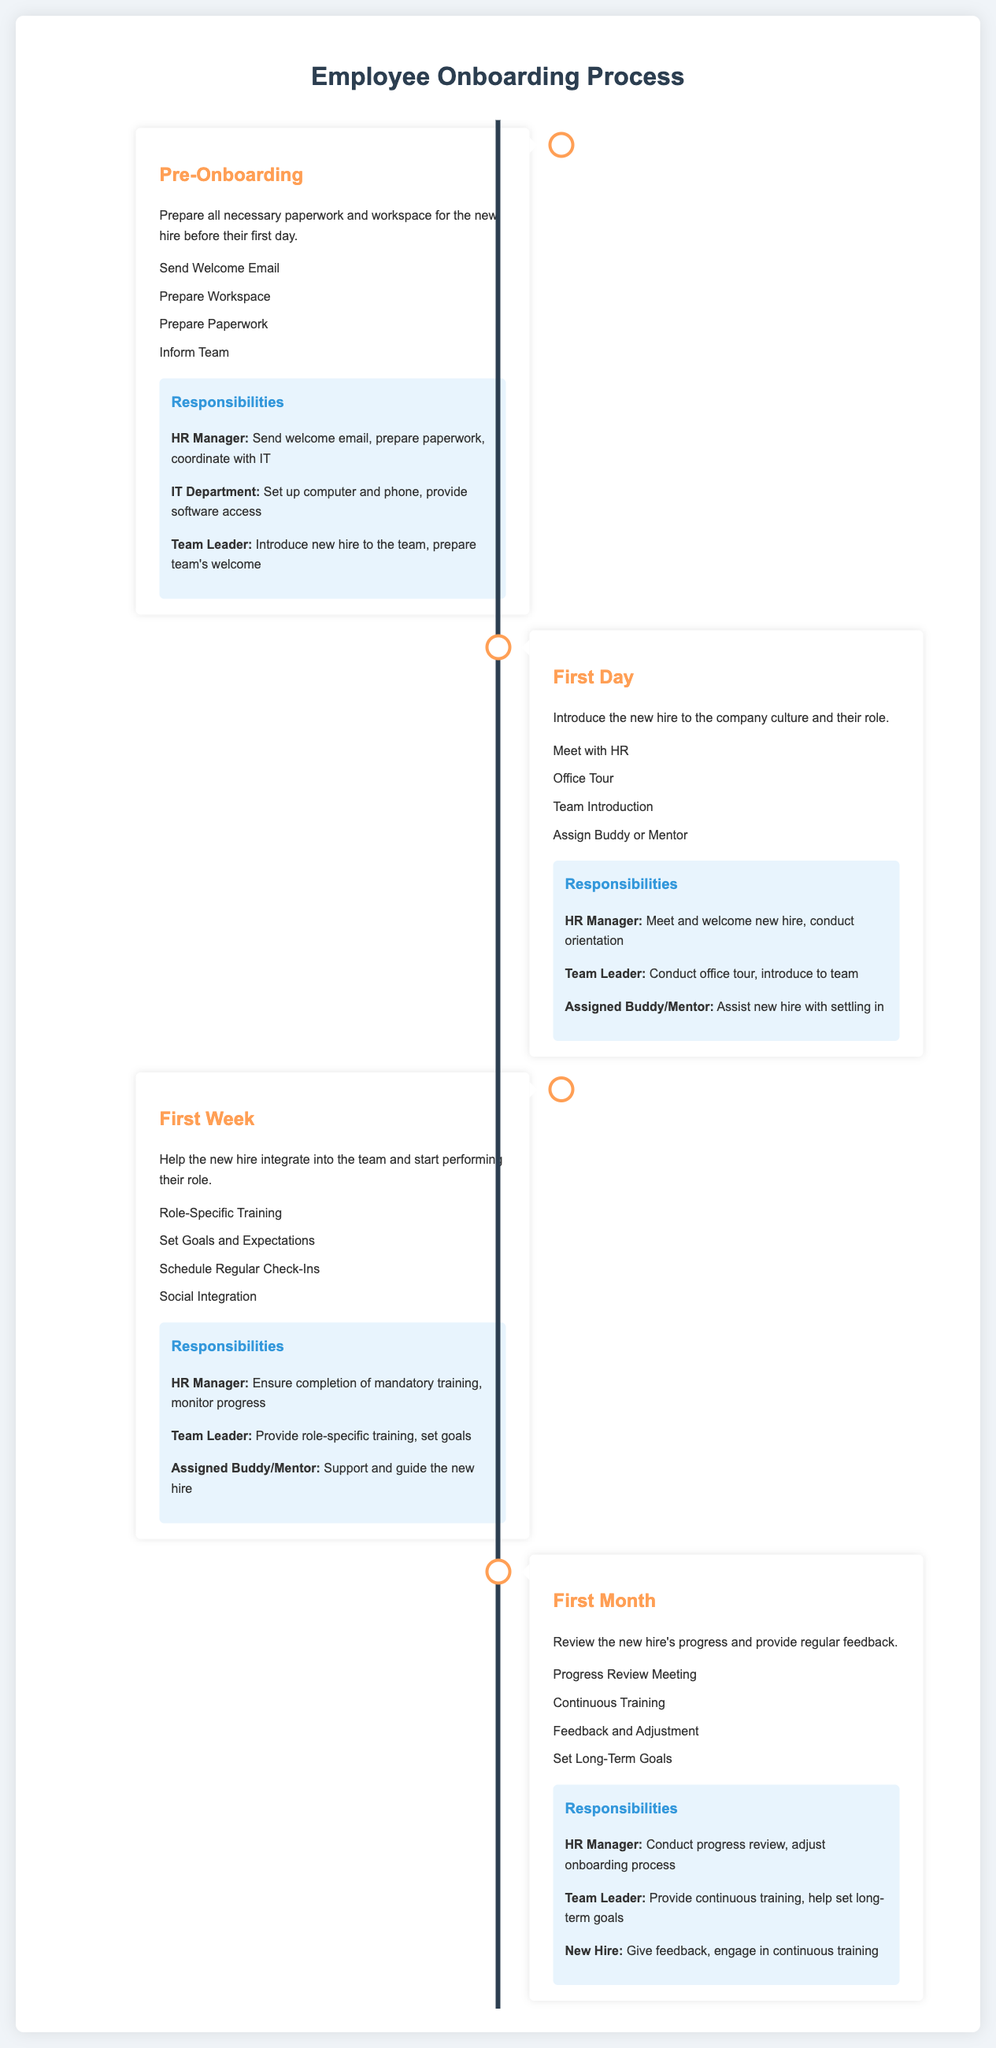What are the key phases of the onboarding process? The document lists four key phases: Pre-Onboarding, First Day, First Week, and First Month.
Answer: Pre-Onboarding, First Day, First Week, First Month Who is responsible for sending the welcome email? The HR Manager is specifically mentioned as responsible for sending the welcome email in the Pre-Onboarding phase.
Answer: HR Manager Which team member is tasked with conducting the office tour? The Team Leader is responsible for conducting the office tour on the First Day according to the document.
Answer: Team Leader What is the main task during the First Month? The main task is to review the new hire's progress and provide regular feedback.
Answer: Review progress How many stages involve providing role-specific training? There are two stages mentioned: First Week and First Month, which involve training.
Answer: Two What should the new hire do during the First Month? The new hire is expected to give feedback and engage in continuous training.
Answer: Give feedback, engage in continuous training In the responsibilities section, who coordinates with IT? The responsibility of coordinating with IT is assigned to the HR Manager in the Pre-Onboarding phase.
Answer: HR Manager What specific responsibility does the Assigned Buddy/Mentor have during the First Week? The Assigned Buddy/Mentor is responsible for supporting and guiding the new hire during the First Week.
Answer: Support and guide How many key responsibilities does the HR Manager have throughout the onboarding process? The HR Manager has specific responsibilities in each of the four phases, totaling four key responsibilities mentioned.
Answer: Four 